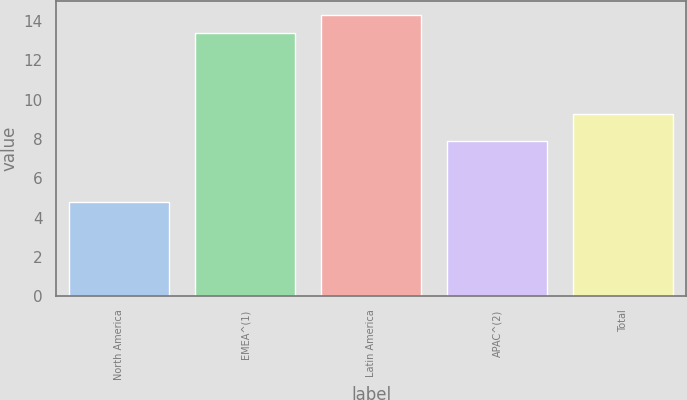<chart> <loc_0><loc_0><loc_500><loc_500><bar_chart><fcel>North America<fcel>EMEA^(1)<fcel>Latin America<fcel>APAC^(2)<fcel>Total<nl><fcel>4.8<fcel>13.4<fcel>14.3<fcel>7.9<fcel>9.3<nl></chart> 